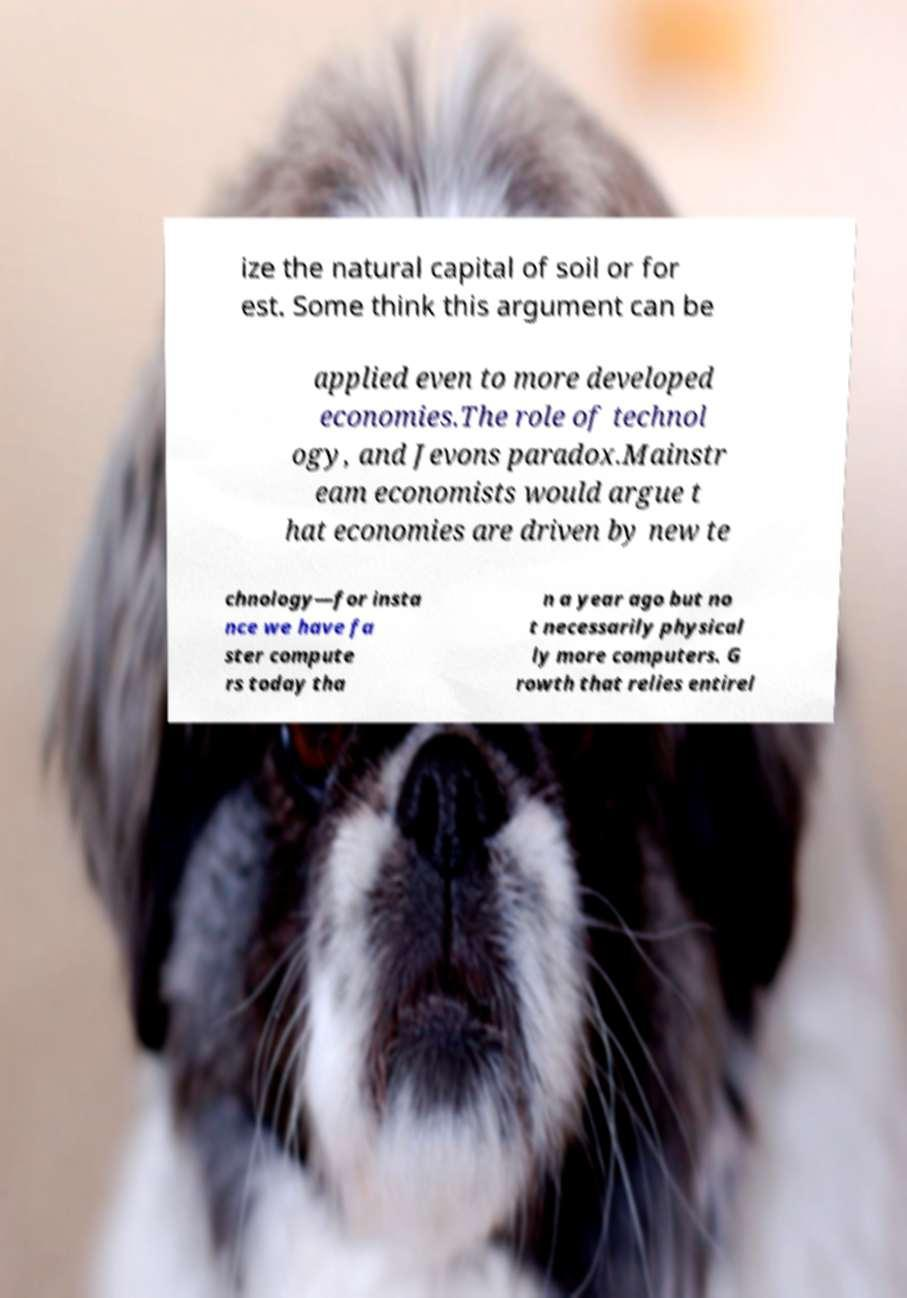For documentation purposes, I need the text within this image transcribed. Could you provide that? ize the natural capital of soil or for est. Some think this argument can be applied even to more developed economies.The role of technol ogy, and Jevons paradox.Mainstr eam economists would argue t hat economies are driven by new te chnology—for insta nce we have fa ster compute rs today tha n a year ago but no t necessarily physical ly more computers. G rowth that relies entirel 